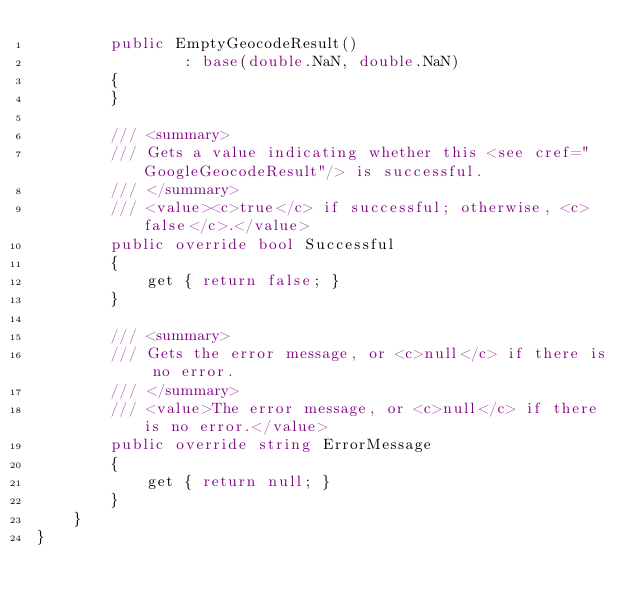Convert code to text. <code><loc_0><loc_0><loc_500><loc_500><_C#_>        public EmptyGeocodeResult() 
                : base(double.NaN, double.NaN)
        {
        }

        /// <summary>
        /// Gets a value indicating whether this <see cref="GoogleGeocodeResult"/> is successful.
        /// </summary>
        /// <value><c>true</c> if successful; otherwise, <c>false</c>.</value>
        public override bool Successful
        {
            get { return false; }
        }

        /// <summary>
        /// Gets the error message, or <c>null</c> if there is no error.
        /// </summary>
        /// <value>The error message, or <c>null</c> if there is no error.</value>
        public override string ErrorMessage
        {
            get { return null; }
        }
    }
}</code> 